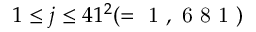Convert formula to latex. <formula><loc_0><loc_0><loc_500><loc_500>1 \leq j \leq 4 1 ^ { 2 } ( = 1 , 6 8 1 )</formula> 